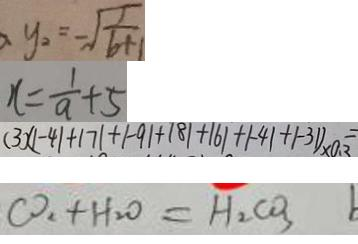<formula> <loc_0><loc_0><loc_500><loc_500>y _ { 2 } = - \sqrt { \frac { 1 } { 6 + 1 } } 
 x = \frac { 1 } { a } + 5 
 ( 3 ) ( \vert - 4 \vert + \vert 7 \vert + \vert - 9 \vert + \vert 8 \vert + \vert 6 \vert + \vert - 4 \vert + \vert - 3 1 ) \times 0 . 3 = 
 C O _ { 2 } + H _ { 2 } O = H _ { 2 } C O _ { 3 } b</formula> 